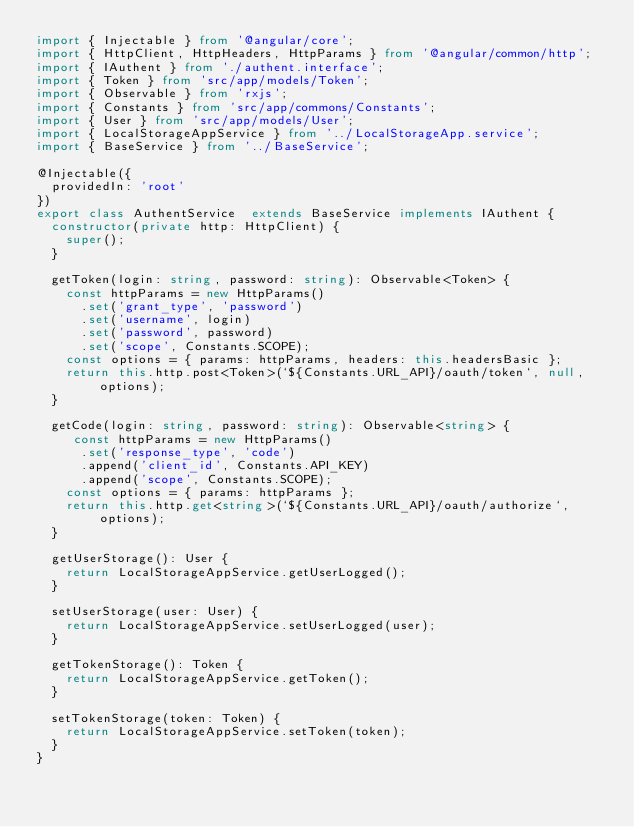Convert code to text. <code><loc_0><loc_0><loc_500><loc_500><_TypeScript_>import { Injectable } from '@angular/core';
import { HttpClient, HttpHeaders, HttpParams } from '@angular/common/http';
import { IAuthent } from './authent.interface';
import { Token } from 'src/app/models/Token';
import { Observable } from 'rxjs';
import { Constants } from 'src/app/commons/Constants';
import { User } from 'src/app/models/User';
import { LocalStorageAppService } from '../LocalStorageApp.service';
import { BaseService } from '../BaseService';

@Injectable({
  providedIn: 'root'
})
export class AuthentService  extends BaseService implements IAuthent {
  constructor(private http: HttpClient) {
    super();
  }

  getToken(login: string, password: string): Observable<Token> {
    const httpParams = new HttpParams()
      .set('grant_type', 'password')
      .set('username', login)
      .set('password', password)
      .set('scope', Constants.SCOPE);
    const options = { params: httpParams, headers: this.headersBasic };
    return this.http.post<Token>(`${Constants.URL_API}/oauth/token`, null, options);
  }

  getCode(login: string, password: string): Observable<string> {
     const httpParams = new HttpParams()
      .set('response_type', 'code')
      .append('client_id', Constants.API_KEY)
      .append('scope', Constants.SCOPE);
    const options = { params: httpParams };
    return this.http.get<string>(`${Constants.URL_API}/oauth/authorize`, options);
  }

  getUserStorage(): User {
    return LocalStorageAppService.getUserLogged();
  }

  setUserStorage(user: User) {
    return LocalStorageAppService.setUserLogged(user);
  }

  getTokenStorage(): Token {
    return LocalStorageAppService.getToken();
  }

  setTokenStorage(token: Token) {
    return LocalStorageAppService.setToken(token);
  }
}
</code> 